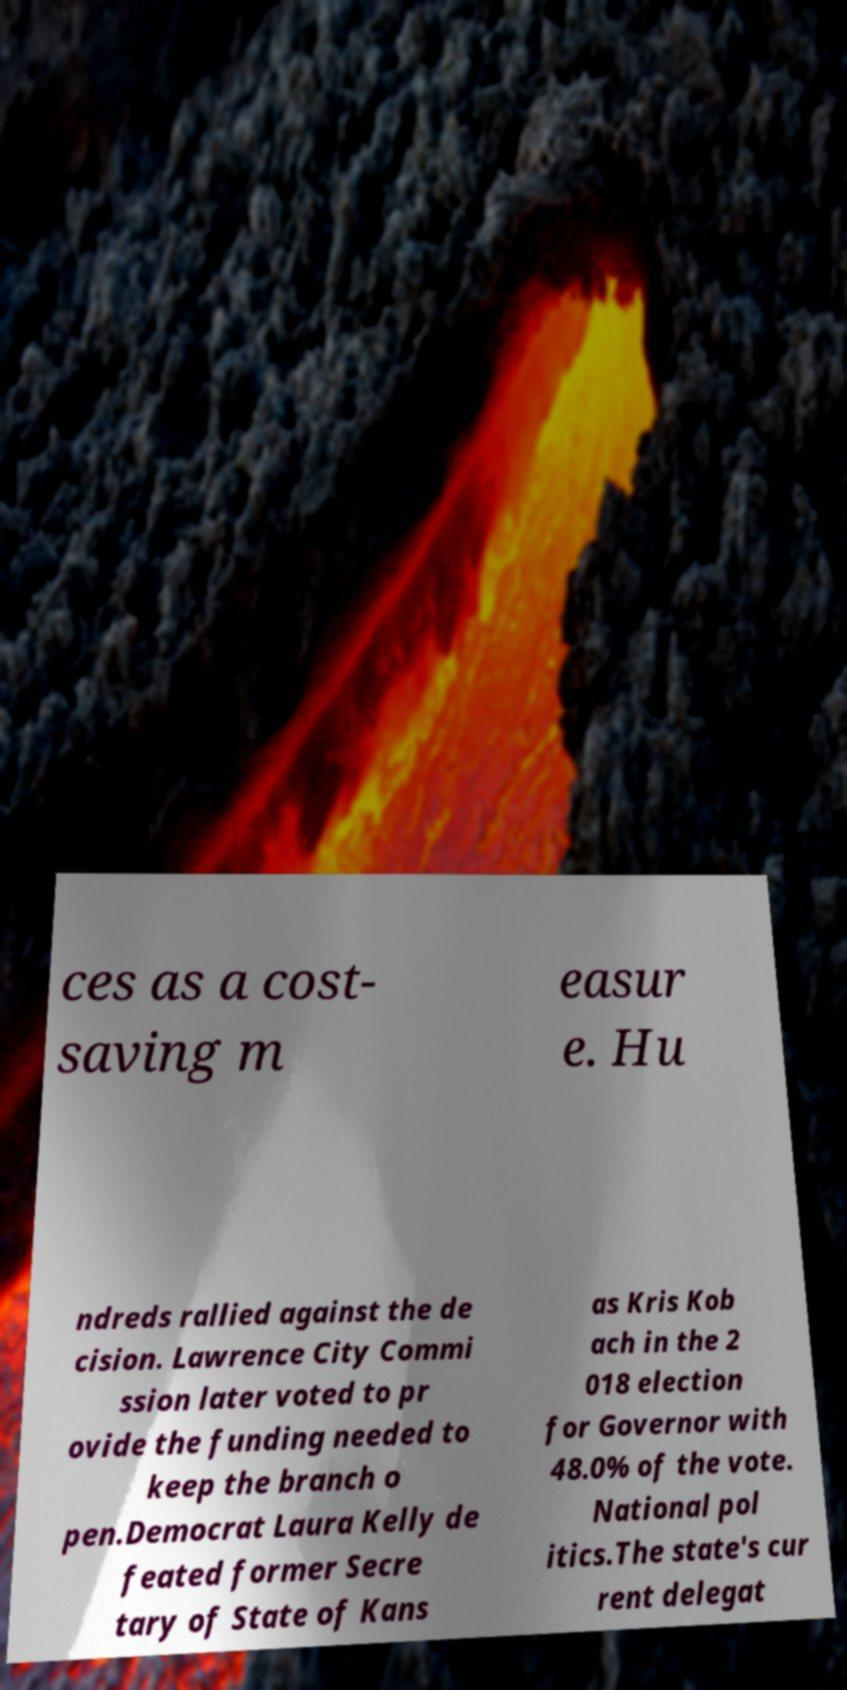Please identify and transcribe the text found in this image. ces as a cost- saving m easur e. Hu ndreds rallied against the de cision. Lawrence City Commi ssion later voted to pr ovide the funding needed to keep the branch o pen.Democrat Laura Kelly de feated former Secre tary of State of Kans as Kris Kob ach in the 2 018 election for Governor with 48.0% of the vote. National pol itics.The state's cur rent delegat 